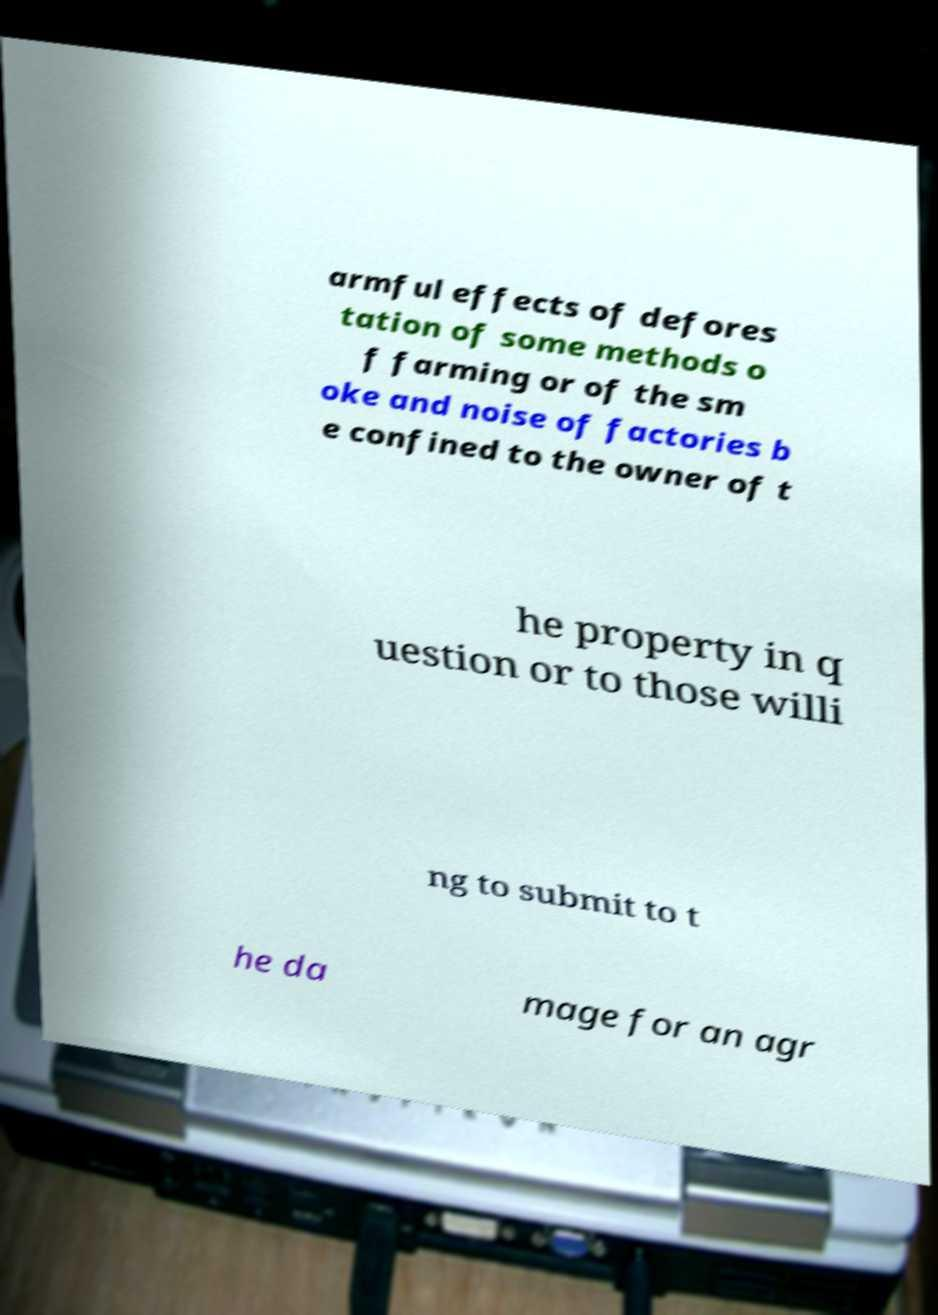There's text embedded in this image that I need extracted. Can you transcribe it verbatim? armful effects of defores tation of some methods o f farming or of the sm oke and noise of factories b e confined to the owner of t he property in q uestion or to those willi ng to submit to t he da mage for an agr 